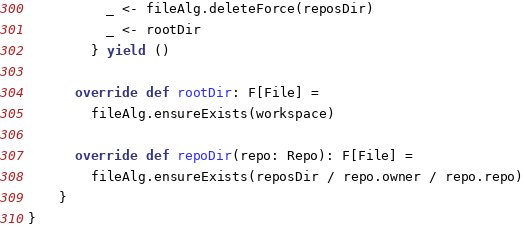<code> <loc_0><loc_0><loc_500><loc_500><_Scala_>          _ <- fileAlg.deleteForce(reposDir)
          _ <- rootDir
        } yield ()

      override def rootDir: F[File] =
        fileAlg.ensureExists(workspace)

      override def repoDir(repo: Repo): F[File] =
        fileAlg.ensureExists(reposDir / repo.owner / repo.repo)
    }
}
</code> 